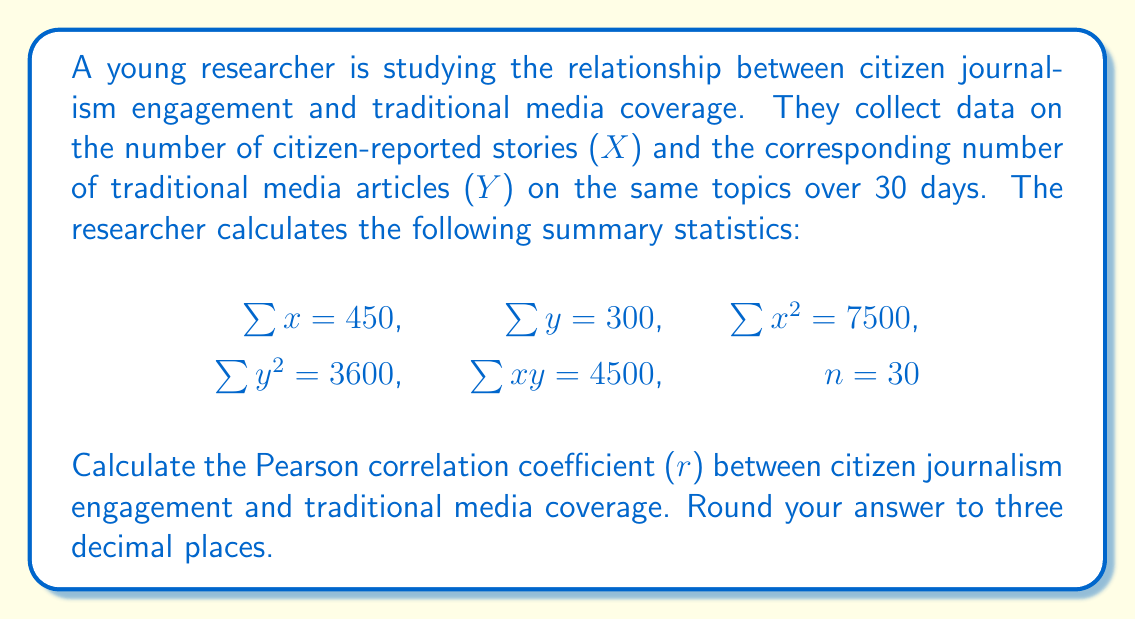Teach me how to tackle this problem. To calculate the Pearson correlation coefficient (r), we'll use the formula:

$$r = \frac{n\sum{xy} - \sum{x}\sum{y}}{\sqrt{[n\sum{x^2} - (\sum{x})^2][n\sum{y^2} - (\sum{y})^2]}}$$

Let's substitute the given values:

1. Calculate $n\sum{xy}$:
   $30 \times 4500 = 135000$

2. Calculate $\sum{x}\sum{y}$:
   $450 \times 300 = 135000$

3. Calculate $n\sum{x^2}$:
   $30 \times 7500 = 225000$

4. Calculate $(\sum{x})^2$:
   $450^2 = 202500$

5. Calculate $n\sum{y^2}$:
   $30 \times 3600 = 108000$

6. Calculate $(\sum{y})^2$:
   $300^2 = 90000$

Now, let's plug these values into the formula:

$$r = \frac{135000 - 135000}{\sqrt{[225000 - 202500][108000 - 90000]}}$$

$$r = \frac{0}{\sqrt{(22500)(18000)}}$$

$$r = \frac{0}{\sqrt{405000000}}$$

$$r = \frac{0}{20124.61}$$

$$r = 0$$

Rounding to three decimal places: $r = 0.000$
Answer: 0.000 